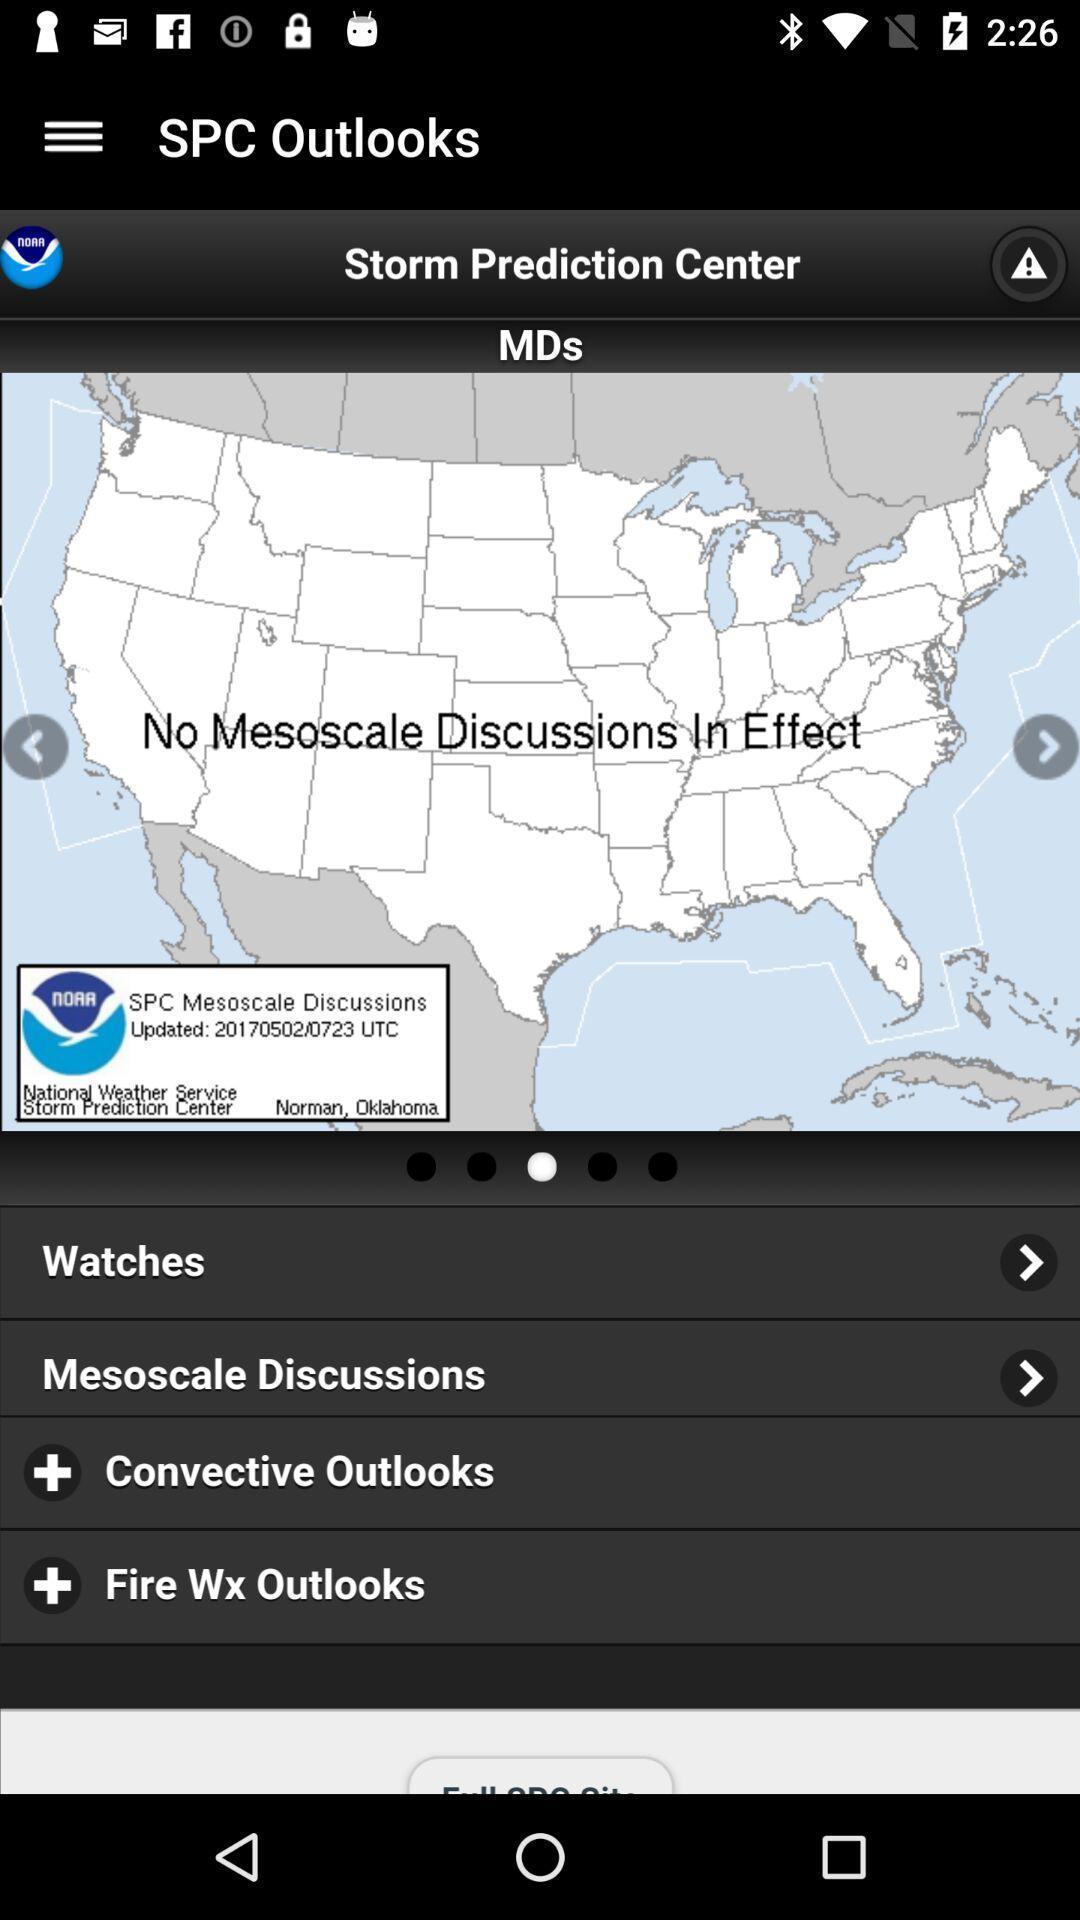Give me a summary of this screen capture. Screen showing a location on a weather prediction app. 